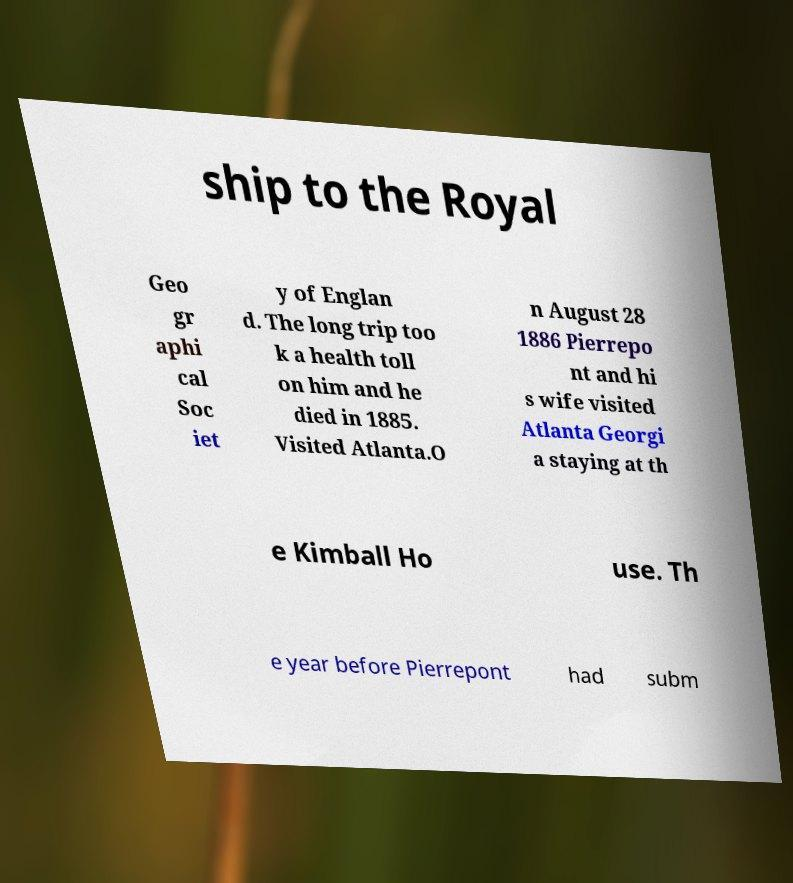I need the written content from this picture converted into text. Can you do that? ship to the Royal Geo gr aphi cal Soc iet y of Englan d. The long trip too k a health toll on him and he died in 1885. Visited Atlanta.O n August 28 1886 Pierrepo nt and hi s wife visited Atlanta Georgi a staying at th e Kimball Ho use. Th e year before Pierrepont had subm 